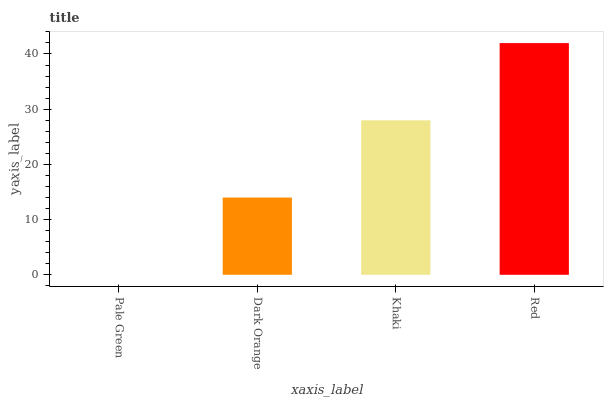Is Pale Green the minimum?
Answer yes or no. Yes. Is Red the maximum?
Answer yes or no. Yes. Is Dark Orange the minimum?
Answer yes or no. No. Is Dark Orange the maximum?
Answer yes or no. No. Is Dark Orange greater than Pale Green?
Answer yes or no. Yes. Is Pale Green less than Dark Orange?
Answer yes or no. Yes. Is Pale Green greater than Dark Orange?
Answer yes or no. No. Is Dark Orange less than Pale Green?
Answer yes or no. No. Is Khaki the high median?
Answer yes or no. Yes. Is Dark Orange the low median?
Answer yes or no. Yes. Is Red the high median?
Answer yes or no. No. Is Khaki the low median?
Answer yes or no. No. 